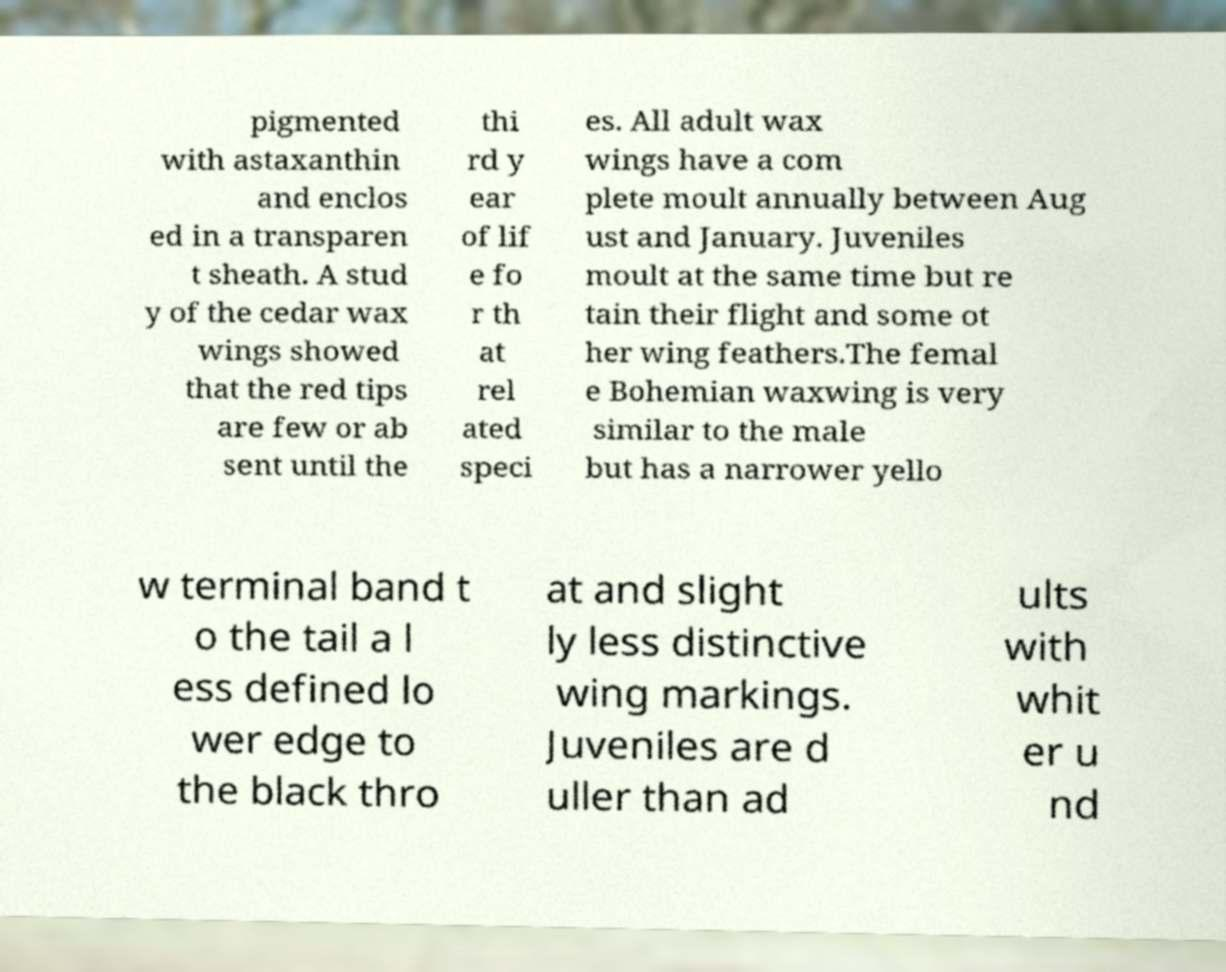Please identify and transcribe the text found in this image. pigmented with astaxanthin and enclos ed in a transparen t sheath. A stud y of the cedar wax wings showed that the red tips are few or ab sent until the thi rd y ear of lif e fo r th at rel ated speci es. All adult wax wings have a com plete moult annually between Aug ust and January. Juveniles moult at the same time but re tain their flight and some ot her wing feathers.The femal e Bohemian waxwing is very similar to the male but has a narrower yello w terminal band t o the tail a l ess defined lo wer edge to the black thro at and slight ly less distinctive wing markings. Juveniles are d uller than ad ults with whit er u nd 